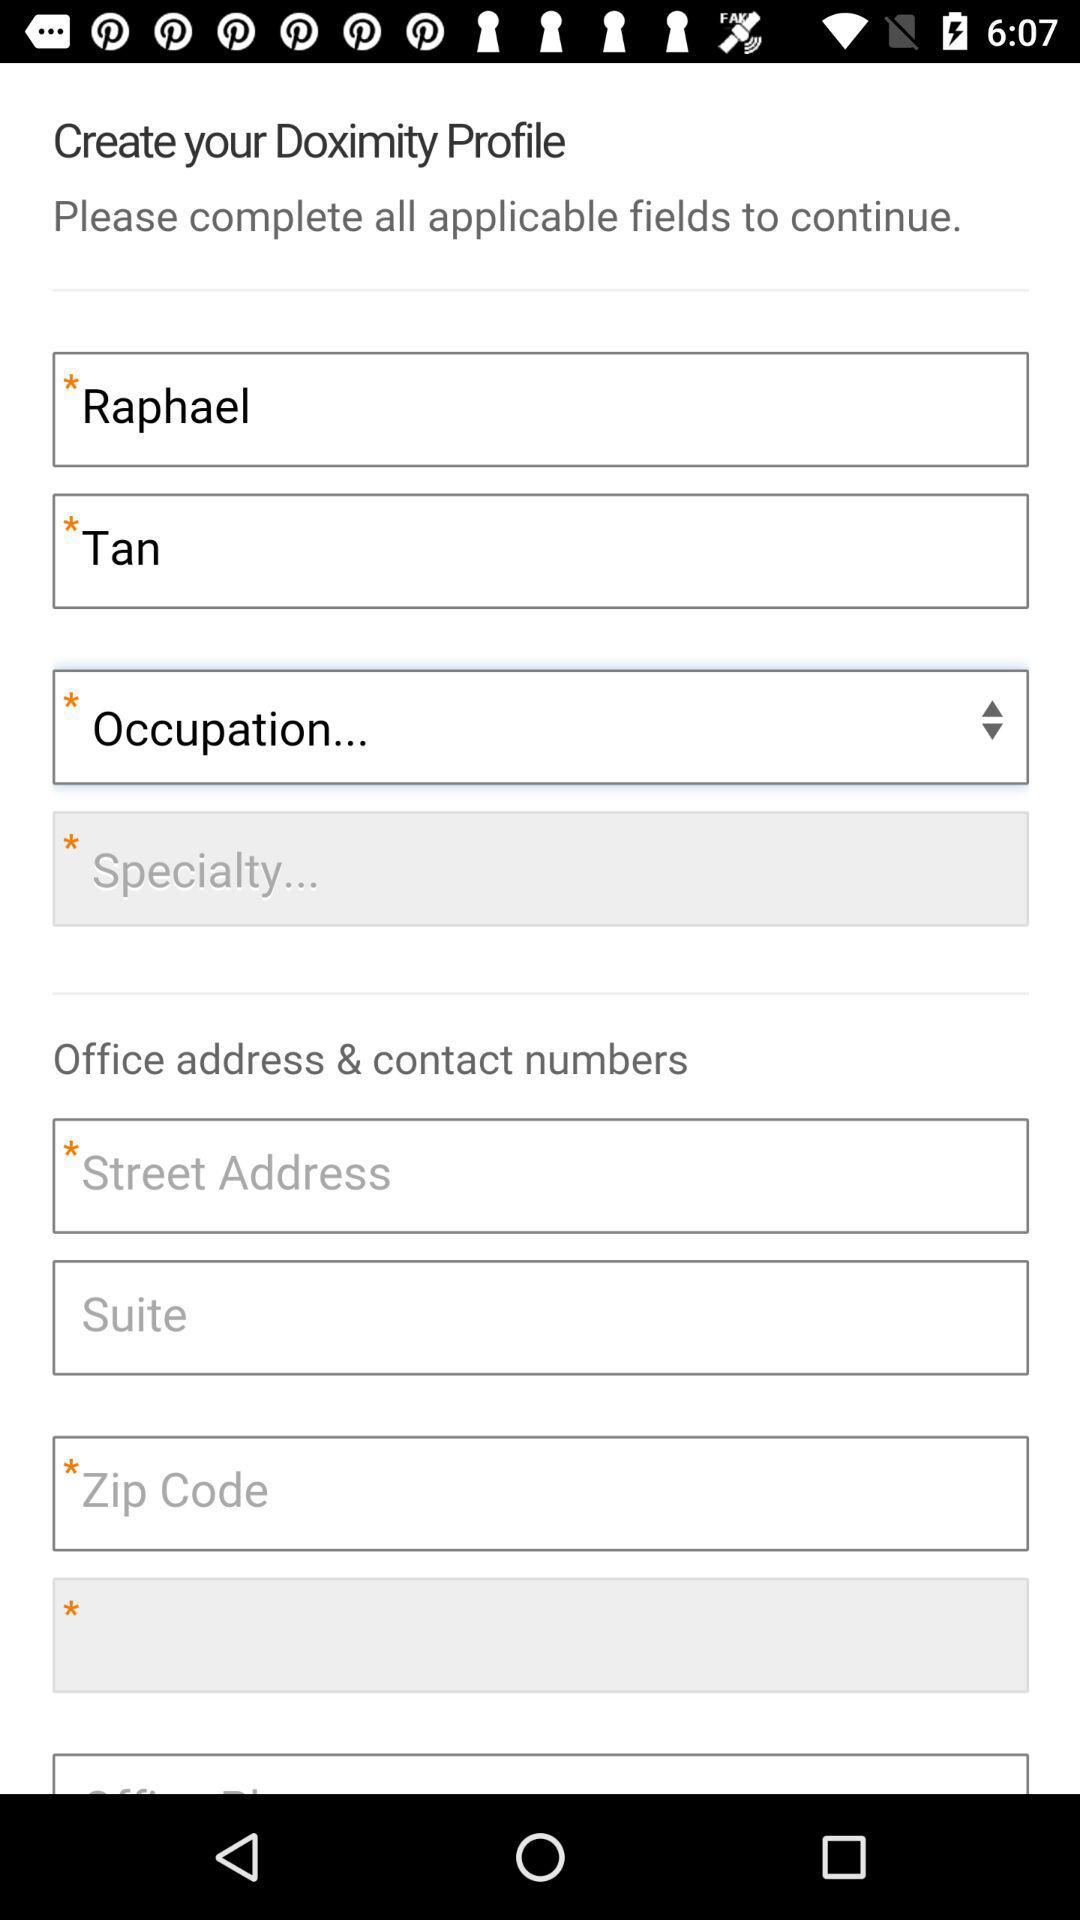How old is Raphael Tan?
When the provided information is insufficient, respond with <no answer>. <no answer> 